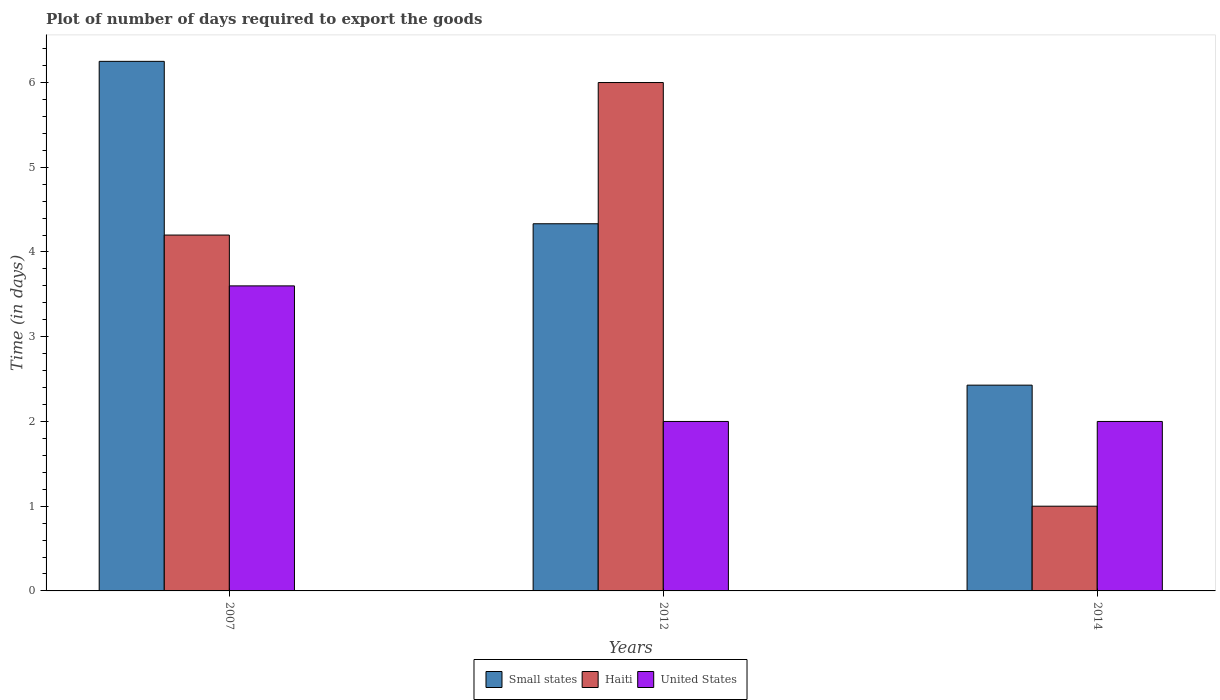How many different coloured bars are there?
Offer a terse response. 3. How many groups of bars are there?
Provide a short and direct response. 3. Are the number of bars on each tick of the X-axis equal?
Ensure brevity in your answer.  Yes. How many bars are there on the 1st tick from the left?
Give a very brief answer. 3. How many bars are there on the 3rd tick from the right?
Make the answer very short. 3. What is the time required to export goods in Small states in 2012?
Provide a short and direct response. 4.33. In which year was the time required to export goods in Small states maximum?
Provide a short and direct response. 2007. In which year was the time required to export goods in United States minimum?
Your answer should be compact. 2012. What is the total time required to export goods in United States in the graph?
Offer a terse response. 7.6. What is the difference between the time required to export goods in Haiti in 2007 and that in 2014?
Offer a terse response. 3.2. What is the difference between the time required to export goods in United States in 2014 and the time required to export goods in Small states in 2012?
Your answer should be compact. -2.33. What is the average time required to export goods in United States per year?
Your response must be concise. 2.53. In the year 2007, what is the difference between the time required to export goods in Small states and time required to export goods in United States?
Keep it short and to the point. 2.65. In how many years, is the time required to export goods in United States greater than 3.2 days?
Your answer should be very brief. 1. What is the ratio of the time required to export goods in Haiti in 2012 to that in 2014?
Your response must be concise. 6. Is the time required to export goods in Haiti in 2012 less than that in 2014?
Offer a very short reply. No. What is the difference between the highest and the second highest time required to export goods in Haiti?
Give a very brief answer. 1.8. What does the 3rd bar from the left in 2014 represents?
Offer a very short reply. United States. What does the 2nd bar from the right in 2014 represents?
Your answer should be very brief. Haiti. Are all the bars in the graph horizontal?
Your response must be concise. No. How many years are there in the graph?
Your answer should be very brief. 3. Does the graph contain any zero values?
Ensure brevity in your answer.  No. Does the graph contain grids?
Offer a very short reply. No. Where does the legend appear in the graph?
Offer a terse response. Bottom center. How are the legend labels stacked?
Make the answer very short. Horizontal. What is the title of the graph?
Provide a succinct answer. Plot of number of days required to export the goods. What is the label or title of the X-axis?
Your answer should be very brief. Years. What is the label or title of the Y-axis?
Provide a succinct answer. Time (in days). What is the Time (in days) in Small states in 2007?
Make the answer very short. 6.25. What is the Time (in days) in United States in 2007?
Give a very brief answer. 3.6. What is the Time (in days) in Small states in 2012?
Provide a succinct answer. 4.33. What is the Time (in days) in Haiti in 2012?
Provide a short and direct response. 6. What is the Time (in days) in Small states in 2014?
Your response must be concise. 2.43. What is the Time (in days) of Haiti in 2014?
Offer a terse response. 1. Across all years, what is the maximum Time (in days) of Small states?
Offer a terse response. 6.25. Across all years, what is the minimum Time (in days) of Small states?
Your answer should be compact. 2.43. Across all years, what is the minimum Time (in days) in Haiti?
Your answer should be very brief. 1. What is the total Time (in days) of Small states in the graph?
Keep it short and to the point. 13.01. What is the difference between the Time (in days) of Small states in 2007 and that in 2012?
Give a very brief answer. 1.92. What is the difference between the Time (in days) in Haiti in 2007 and that in 2012?
Your answer should be compact. -1.8. What is the difference between the Time (in days) of Small states in 2007 and that in 2014?
Your answer should be very brief. 3.82. What is the difference between the Time (in days) of Haiti in 2007 and that in 2014?
Make the answer very short. 3.2. What is the difference between the Time (in days) of Small states in 2012 and that in 2014?
Your answer should be very brief. 1.9. What is the difference between the Time (in days) of Haiti in 2012 and that in 2014?
Offer a terse response. 5. What is the difference between the Time (in days) in United States in 2012 and that in 2014?
Provide a succinct answer. 0. What is the difference between the Time (in days) of Small states in 2007 and the Time (in days) of United States in 2012?
Keep it short and to the point. 4.25. What is the difference between the Time (in days) in Haiti in 2007 and the Time (in days) in United States in 2012?
Provide a succinct answer. 2.2. What is the difference between the Time (in days) in Small states in 2007 and the Time (in days) in Haiti in 2014?
Provide a short and direct response. 5.25. What is the difference between the Time (in days) in Small states in 2007 and the Time (in days) in United States in 2014?
Your answer should be very brief. 4.25. What is the difference between the Time (in days) of Haiti in 2007 and the Time (in days) of United States in 2014?
Provide a short and direct response. 2.2. What is the difference between the Time (in days) in Small states in 2012 and the Time (in days) in United States in 2014?
Keep it short and to the point. 2.33. What is the average Time (in days) of Small states per year?
Offer a very short reply. 4.34. What is the average Time (in days) in Haiti per year?
Ensure brevity in your answer.  3.73. What is the average Time (in days) of United States per year?
Your answer should be very brief. 2.53. In the year 2007, what is the difference between the Time (in days) in Small states and Time (in days) in Haiti?
Give a very brief answer. 2.05. In the year 2007, what is the difference between the Time (in days) of Small states and Time (in days) of United States?
Provide a succinct answer. 2.65. In the year 2007, what is the difference between the Time (in days) in Haiti and Time (in days) in United States?
Offer a very short reply. 0.6. In the year 2012, what is the difference between the Time (in days) of Small states and Time (in days) of Haiti?
Provide a succinct answer. -1.67. In the year 2012, what is the difference between the Time (in days) in Small states and Time (in days) in United States?
Ensure brevity in your answer.  2.33. In the year 2012, what is the difference between the Time (in days) in Haiti and Time (in days) in United States?
Your answer should be very brief. 4. In the year 2014, what is the difference between the Time (in days) of Small states and Time (in days) of Haiti?
Your answer should be very brief. 1.43. In the year 2014, what is the difference between the Time (in days) in Small states and Time (in days) in United States?
Provide a succinct answer. 0.43. What is the ratio of the Time (in days) in Small states in 2007 to that in 2012?
Your response must be concise. 1.44. What is the ratio of the Time (in days) of Haiti in 2007 to that in 2012?
Your response must be concise. 0.7. What is the ratio of the Time (in days) of Small states in 2007 to that in 2014?
Offer a terse response. 2.57. What is the ratio of the Time (in days) in Haiti in 2007 to that in 2014?
Keep it short and to the point. 4.2. What is the ratio of the Time (in days) in United States in 2007 to that in 2014?
Offer a very short reply. 1.8. What is the ratio of the Time (in days) of Small states in 2012 to that in 2014?
Provide a succinct answer. 1.78. What is the ratio of the Time (in days) of Haiti in 2012 to that in 2014?
Ensure brevity in your answer.  6. What is the difference between the highest and the second highest Time (in days) in Small states?
Offer a very short reply. 1.92. What is the difference between the highest and the second highest Time (in days) of Haiti?
Keep it short and to the point. 1.8. What is the difference between the highest and the second highest Time (in days) in United States?
Your answer should be compact. 1.6. What is the difference between the highest and the lowest Time (in days) of Small states?
Give a very brief answer. 3.82. What is the difference between the highest and the lowest Time (in days) in Haiti?
Give a very brief answer. 5. What is the difference between the highest and the lowest Time (in days) of United States?
Keep it short and to the point. 1.6. 